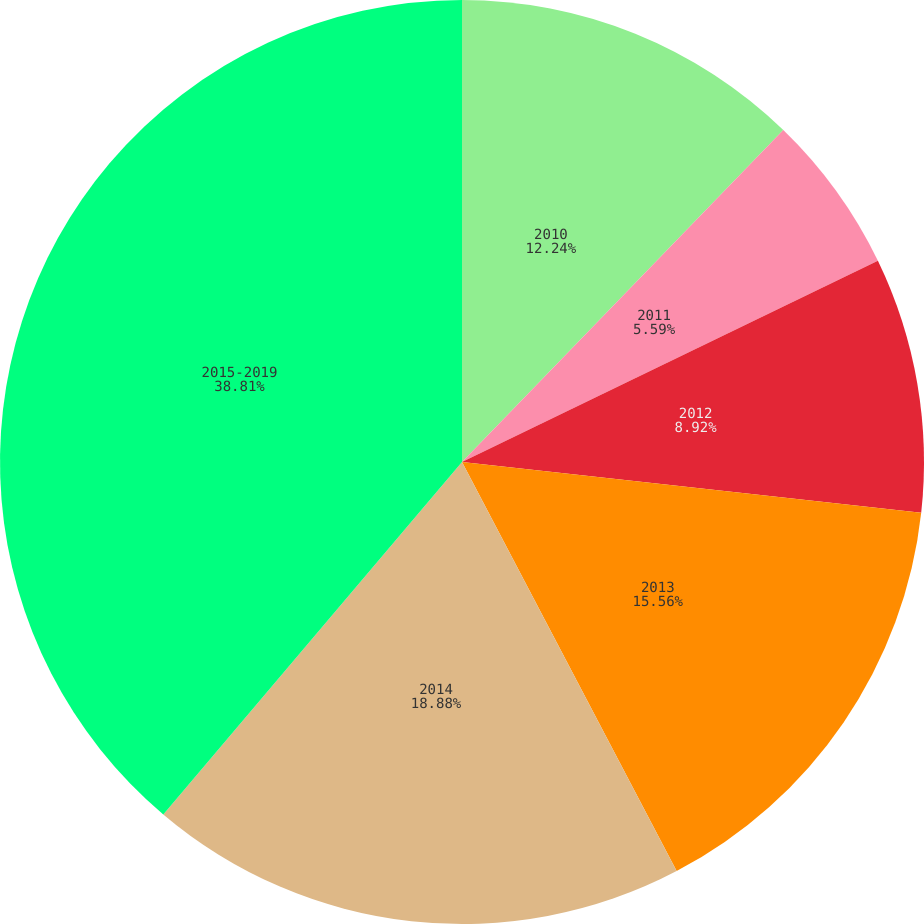Convert chart to OTSL. <chart><loc_0><loc_0><loc_500><loc_500><pie_chart><fcel>2010<fcel>2011<fcel>2012<fcel>2013<fcel>2014<fcel>2015-2019<nl><fcel>12.24%<fcel>5.59%<fcel>8.92%<fcel>15.56%<fcel>18.88%<fcel>38.81%<nl></chart> 